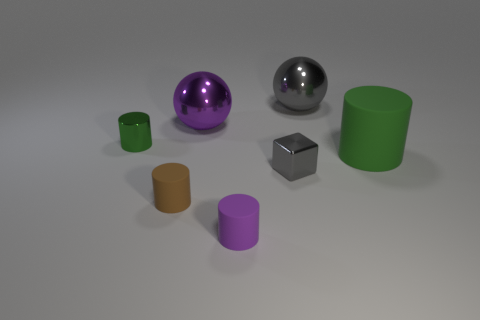Add 2 purple matte cylinders. How many objects exist? 9 Subtract all green matte cylinders. How many cylinders are left? 3 Subtract all cylinders. How many objects are left? 3 Subtract 4 cylinders. How many cylinders are left? 0 Subtract all cyan blocks. Subtract all yellow spheres. How many blocks are left? 1 Subtract all purple balls. How many red cubes are left? 0 Subtract all purple metallic balls. Subtract all small purple cylinders. How many objects are left? 5 Add 6 large spheres. How many large spheres are left? 8 Add 1 large yellow metallic balls. How many large yellow metallic balls exist? 1 Subtract all gray balls. How many balls are left? 1 